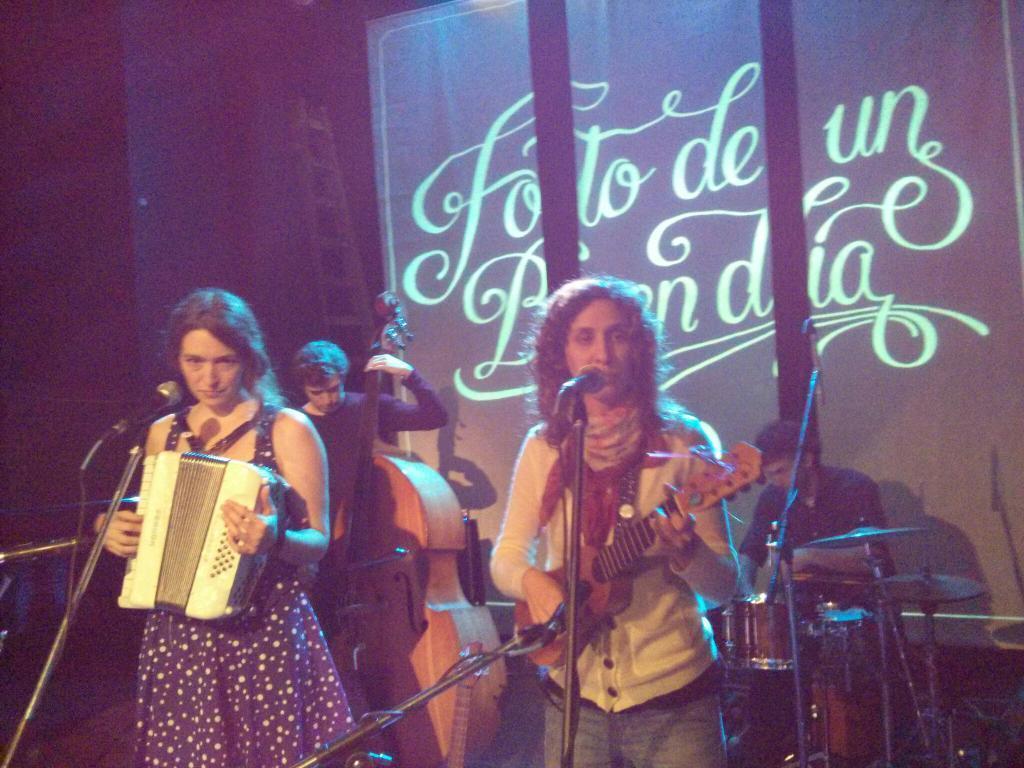How would you summarize this image in a sentence or two? In the image we can see there are people who are standing and holding musical instruments in their hand. 